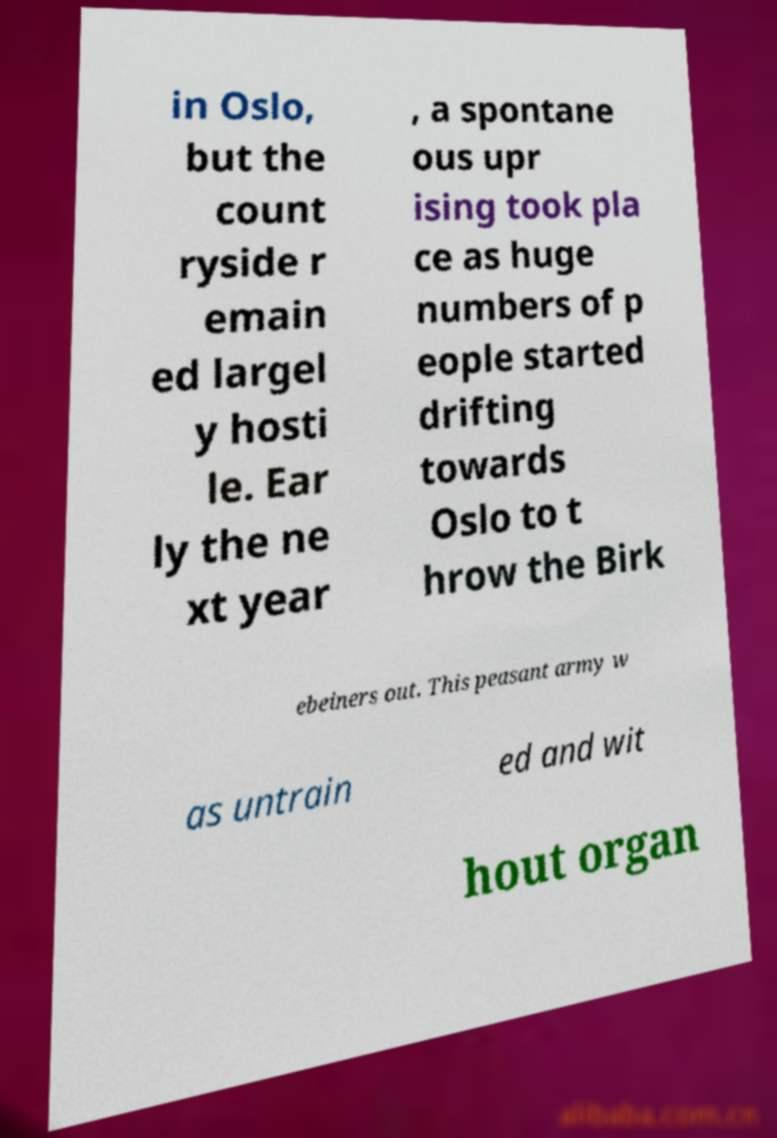For documentation purposes, I need the text within this image transcribed. Could you provide that? in Oslo, but the count ryside r emain ed largel y hosti le. Ear ly the ne xt year , a spontane ous upr ising took pla ce as huge numbers of p eople started drifting towards Oslo to t hrow the Birk ebeiners out. This peasant army w as untrain ed and wit hout organ 